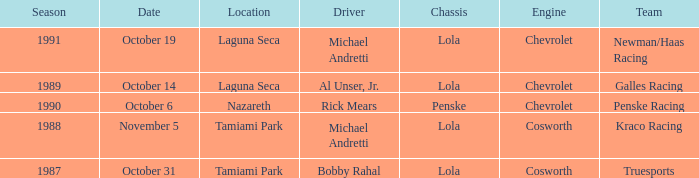What engine does Galles Racing use? Chevrolet. 